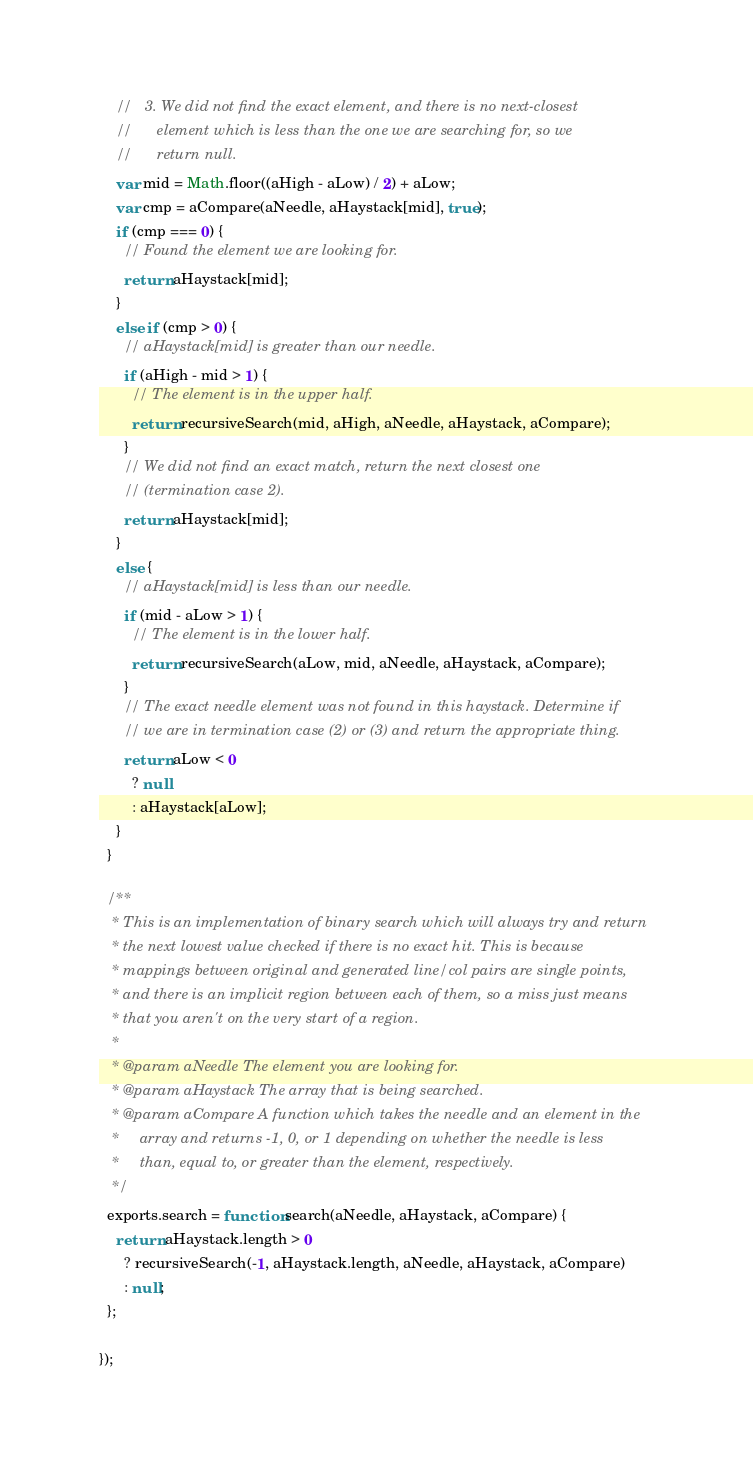Convert code to text. <code><loc_0><loc_0><loc_500><loc_500><_JavaScript_>    //   3. We did not find the exact element, and there is no next-closest
    //      element which is less than the one we are searching for, so we
    //      return null.
    var mid = Math.floor((aHigh - aLow) / 2) + aLow;
    var cmp = aCompare(aNeedle, aHaystack[mid], true);
    if (cmp === 0) {
      // Found the element we are looking for.
      return aHaystack[mid];
    }
    else if (cmp > 0) {
      // aHaystack[mid] is greater than our needle.
      if (aHigh - mid > 1) {
        // The element is in the upper half.
        return recursiveSearch(mid, aHigh, aNeedle, aHaystack, aCompare);
      }
      // We did not find an exact match, return the next closest one
      // (termination case 2).
      return aHaystack[mid];
    }
    else {
      // aHaystack[mid] is less than our needle.
      if (mid - aLow > 1) {
        // The element is in the lower half.
        return recursiveSearch(aLow, mid, aNeedle, aHaystack, aCompare);
      }
      // The exact needle element was not found in this haystack. Determine if
      // we are in termination case (2) or (3) and return the appropriate thing.
      return aLow < 0
        ? null
        : aHaystack[aLow];
    }
  }

  /**
   * This is an implementation of binary search which will always try and return
   * the next lowest value checked if there is no exact hit. This is because
   * mappings between original and generated line/col pairs are single points,
   * and there is an implicit region between each of them, so a miss just means
   * that you aren't on the very start of a region.
   *
   * @param aNeedle The element you are looking for.
   * @param aHaystack The array that is being searched.
   * @param aCompare A function which takes the needle and an element in the
   *     array and returns -1, 0, or 1 depending on whether the needle is less
   *     than, equal to, or greater than the element, respectively.
   */
  exports.search = function search(aNeedle, aHaystack, aCompare) {
    return aHaystack.length > 0
      ? recursiveSearch(-1, aHaystack.length, aNeedle, aHaystack, aCompare)
      : null;
  };

});
</code> 